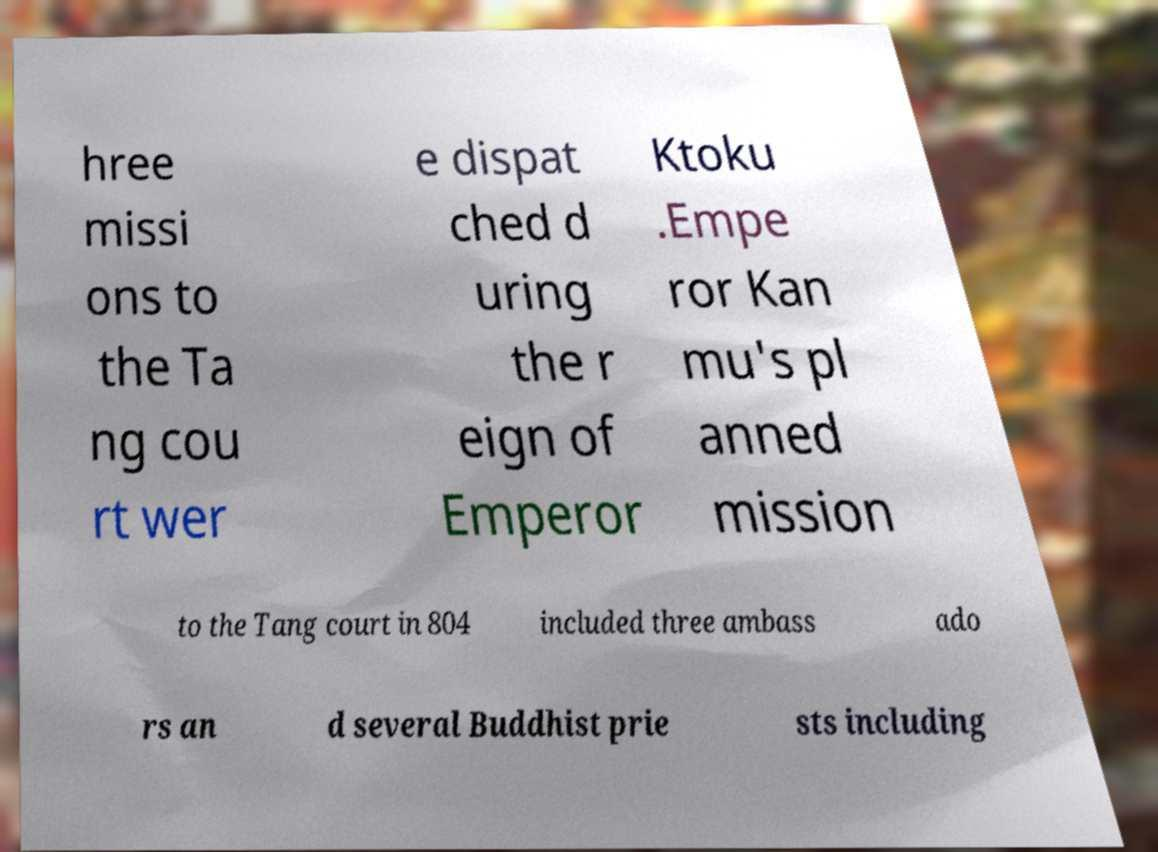I need the written content from this picture converted into text. Can you do that? hree missi ons to the Ta ng cou rt wer e dispat ched d uring the r eign of Emperor Ktoku .Empe ror Kan mu's pl anned mission to the Tang court in 804 included three ambass ado rs an d several Buddhist prie sts including 